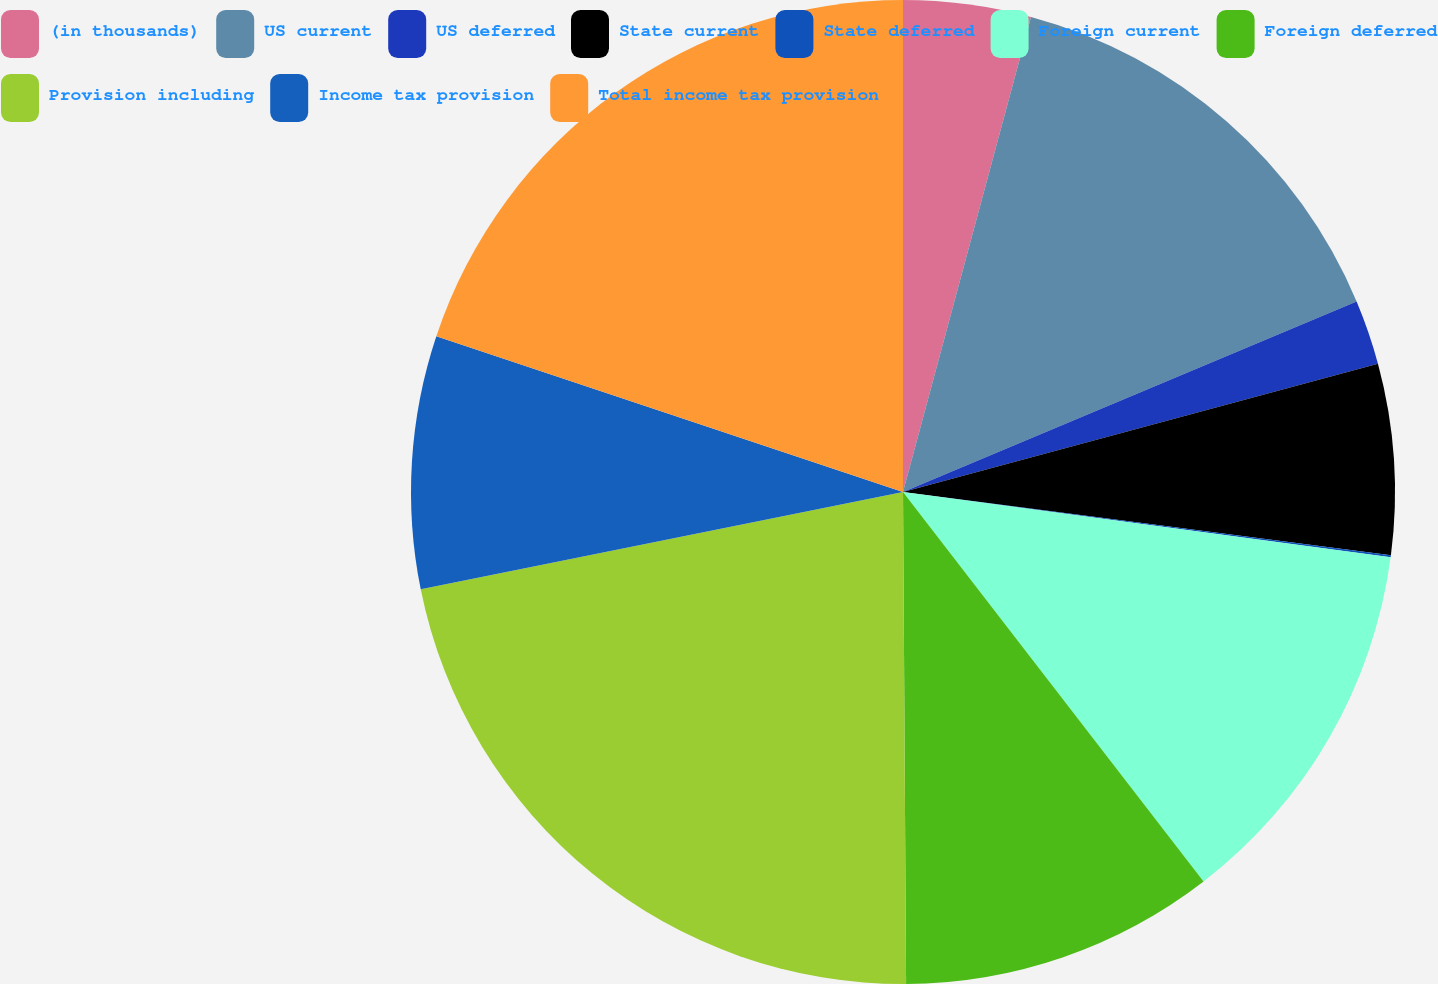Convert chart to OTSL. <chart><loc_0><loc_0><loc_500><loc_500><pie_chart><fcel>(in thousands)<fcel>US current<fcel>US deferred<fcel>State current<fcel>State deferred<fcel>Foreign current<fcel>Foreign deferred<fcel>Provision including<fcel>Income tax provision<fcel>Total income tax provision<nl><fcel>4.19%<fcel>14.48%<fcel>2.13%<fcel>6.25%<fcel>0.07%<fcel>12.42%<fcel>10.36%<fcel>21.93%<fcel>8.3%<fcel>19.87%<nl></chart> 